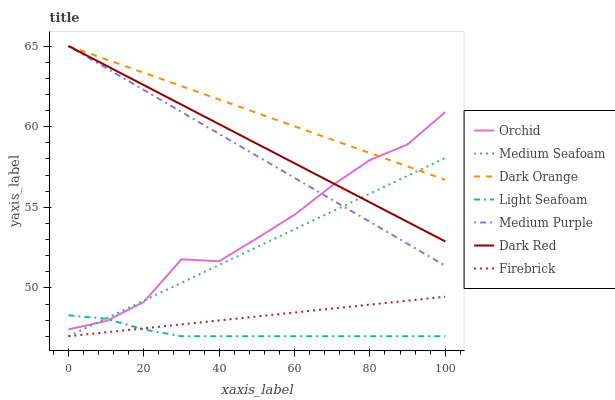Does Light Seafoam have the minimum area under the curve?
Answer yes or no. Yes. Does Dark Orange have the maximum area under the curve?
Answer yes or no. Yes. Does Dark Red have the minimum area under the curve?
Answer yes or no. No. Does Dark Red have the maximum area under the curve?
Answer yes or no. No. Is Dark Orange the smoothest?
Answer yes or no. Yes. Is Orchid the roughest?
Answer yes or no. Yes. Is Dark Red the smoothest?
Answer yes or no. No. Is Dark Red the roughest?
Answer yes or no. No. Does Firebrick have the lowest value?
Answer yes or no. Yes. Does Dark Red have the lowest value?
Answer yes or no. No. Does Medium Purple have the highest value?
Answer yes or no. Yes. Does Firebrick have the highest value?
Answer yes or no. No. Is Light Seafoam less than Dark Orange?
Answer yes or no. Yes. Is Medium Purple greater than Light Seafoam?
Answer yes or no. Yes. Does Orchid intersect Medium Purple?
Answer yes or no. Yes. Is Orchid less than Medium Purple?
Answer yes or no. No. Is Orchid greater than Medium Purple?
Answer yes or no. No. Does Light Seafoam intersect Dark Orange?
Answer yes or no. No. 